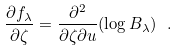Convert formula to latex. <formula><loc_0><loc_0><loc_500><loc_500>\frac { \partial f _ { \lambda } } { \partial \zeta } = \frac { \partial ^ { 2 } } { \partial \zeta \partial u } ( \log B _ { \lambda } ) \ .</formula> 